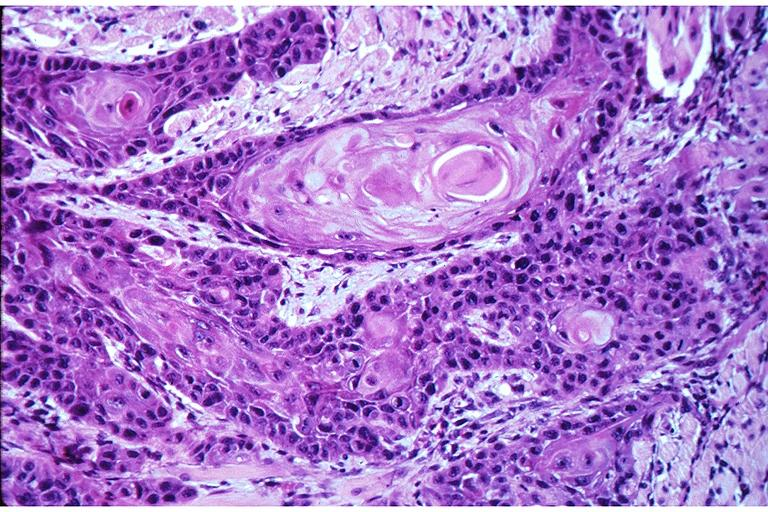s oral present?
Answer the question using a single word or phrase. Yes 